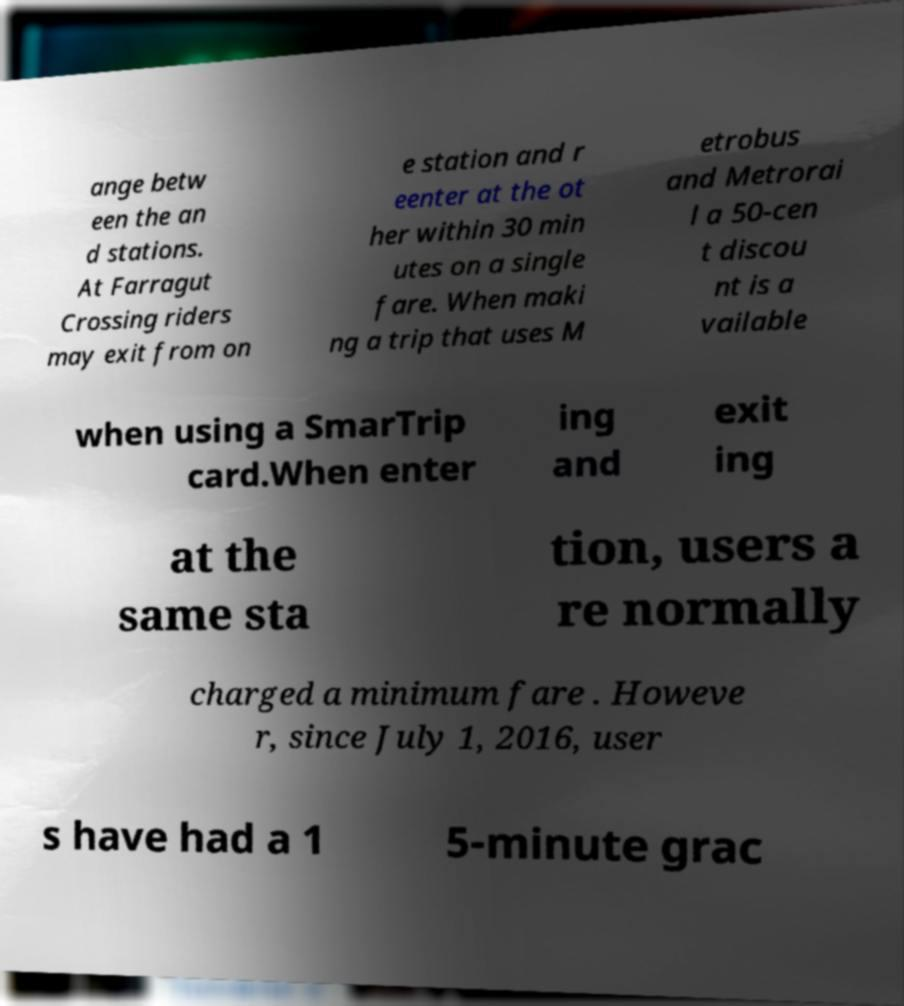What messages or text are displayed in this image? I need them in a readable, typed format. ange betw een the an d stations. At Farragut Crossing riders may exit from on e station and r eenter at the ot her within 30 min utes on a single fare. When maki ng a trip that uses M etrobus and Metrorai l a 50-cen t discou nt is a vailable when using a SmarTrip card.When enter ing and exit ing at the same sta tion, users a re normally charged a minimum fare . Howeve r, since July 1, 2016, user s have had a 1 5-minute grac 